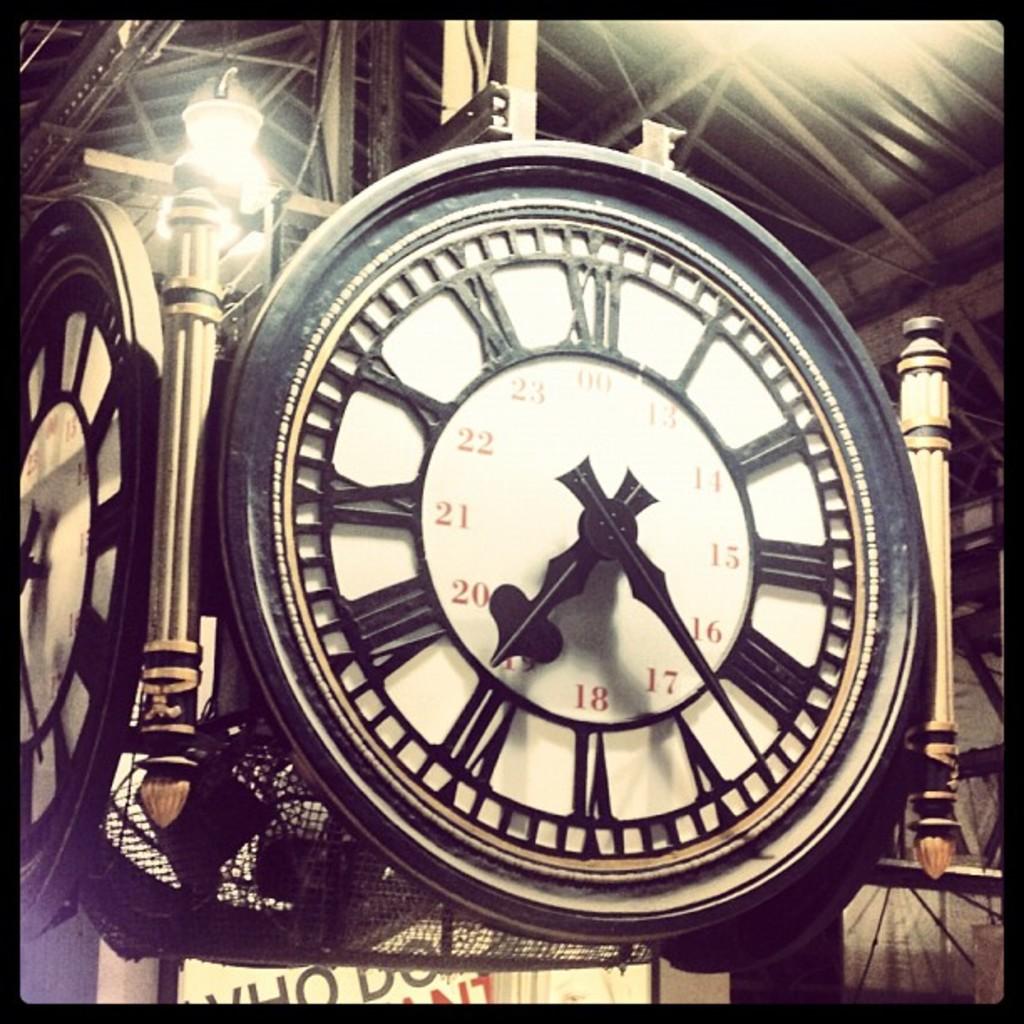What does the number at the top?
Keep it short and to the point. 00. 